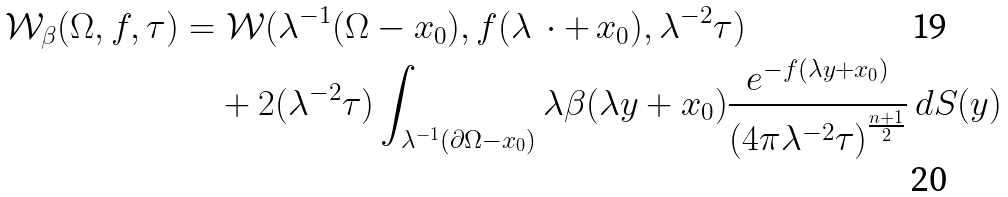Convert formula to latex. <formula><loc_0><loc_0><loc_500><loc_500>\mathcal { W } _ { \beta } ( \Omega , f , \tau ) & = \mathcal { W } ( \lambda ^ { - 1 } ( \Omega - x _ { 0 } ) , f ( \lambda \, \cdot + \, x _ { 0 } ) , \lambda ^ { - 2 } \tau ) \\ & \quad + 2 ( \lambda ^ { - 2 } \tau ) \int _ { \lambda ^ { - 1 } ( \partial \Omega - x _ { 0 } ) } \lambda \beta ( \lambda y + x _ { 0 } ) \frac { e ^ { - f ( \lambda y + x _ { 0 } ) } } { \left ( 4 \pi \lambda ^ { - 2 } \tau \right ) ^ { \frac { n + 1 } { 2 } } } \, d S ( y )</formula> 